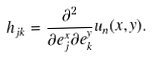<formula> <loc_0><loc_0><loc_500><loc_500>h _ { j k } = \frac { \partial ^ { 2 } } { \partial e _ { j } ^ { x } \partial e _ { k } ^ { y } } u _ { n } ( x , y ) .</formula> 